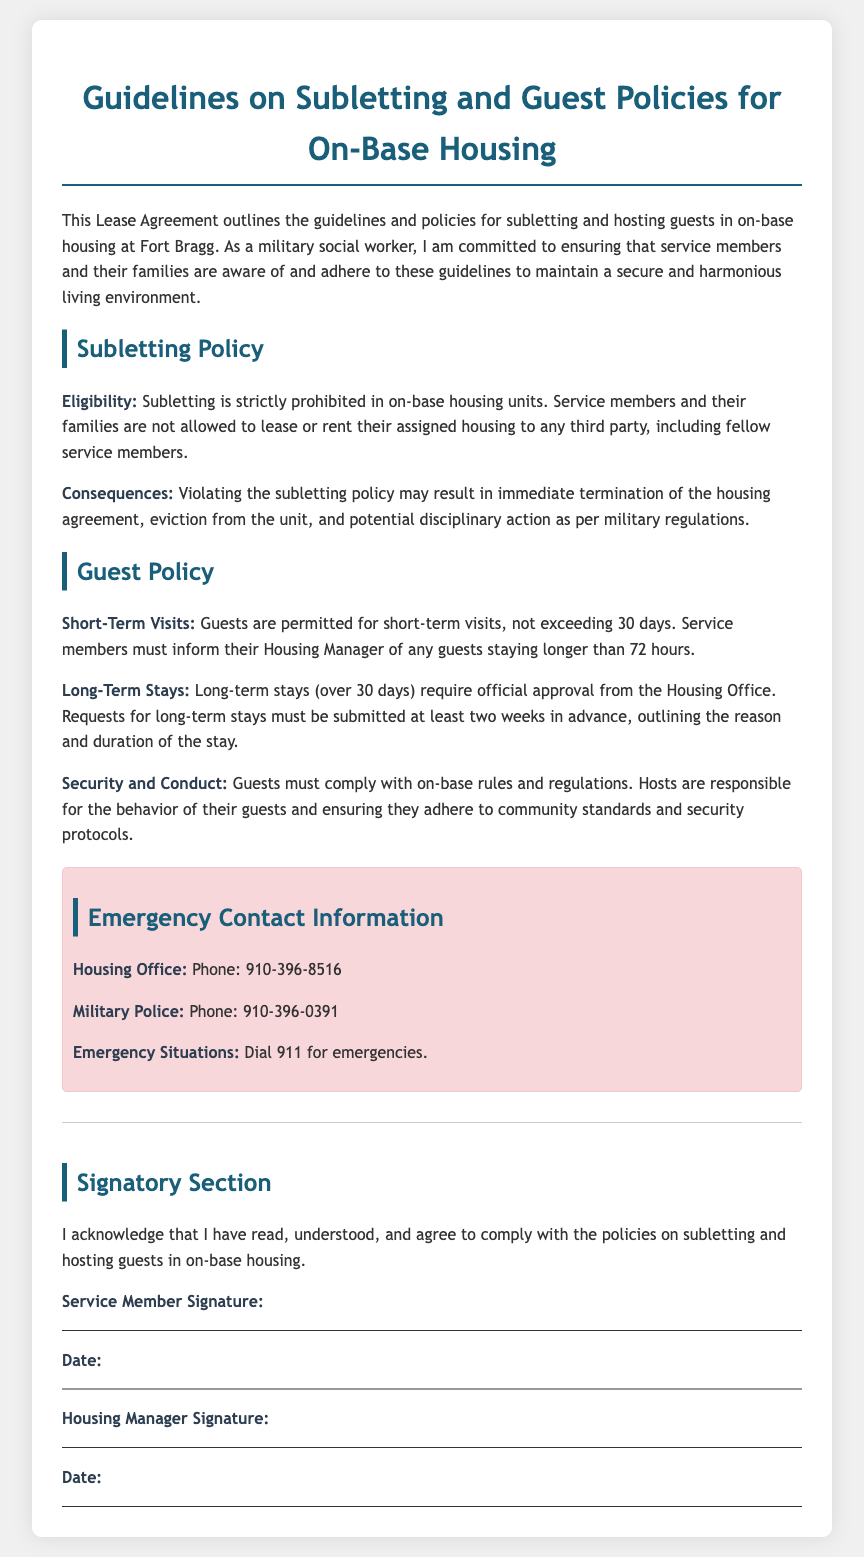What is the main purpose of the document? The document outlines guidelines and policies for subletting and hosting guests in on-base housing at Fort Bragg.
Answer: guidelines and policies for subletting and hosting guests Is subletting allowed in on-base housing? The lease agreement states that subletting is strictly prohibited in on-base housing units.
Answer: prohibited What is the phone number for the Housing Office? The document provides specific contact numbers, and the Housing Office phone number is mentioned.
Answer: 910-396-8516 How long can guests stay without needing to inform the Housing Manager? Guests are permitted for short-term visits not exceeding a specific duration without notification.
Answer: 72 hours What must be submitted for long-term stays? A request must be submitted outlining the reason and duration for long-term stays over 30 days.
Answer: request What can happen if the subletting policy is violated? The consequences of violations are immediately stated in the document.
Answer: eviction When must requests for long-term stays be made? The guidelines specify a timeframe for submitting requests concerning long-term stays.
Answer: two weeks in advance Who must sign the lease agreement? The document outlines a signature section that requires signatures from both parties.
Answer: Service Member and Housing Manager What is the emergency contact number for Military Police? The document lists emergency contact information, including Military Police.
Answer: 910-396-0391 